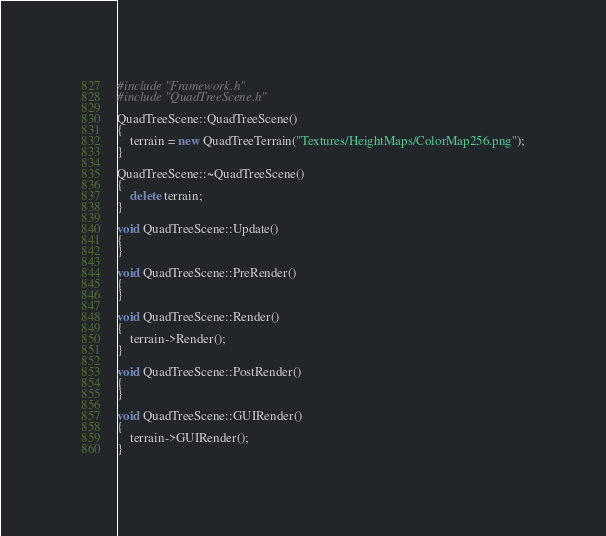Convert code to text. <code><loc_0><loc_0><loc_500><loc_500><_C++_>#include "Framework.h"
#include "QuadTreeScene.h"

QuadTreeScene::QuadTreeScene()
{
	terrain = new QuadTreeTerrain("Textures/HeightMaps/ColorMap256.png");
}

QuadTreeScene::~QuadTreeScene()
{
	delete terrain;
}

void QuadTreeScene::Update()
{
}

void QuadTreeScene::PreRender()
{
}

void QuadTreeScene::Render()
{
	terrain->Render();
}

void QuadTreeScene::PostRender()
{
}

void QuadTreeScene::GUIRender()
{
	terrain->GUIRender();
}
</code> 